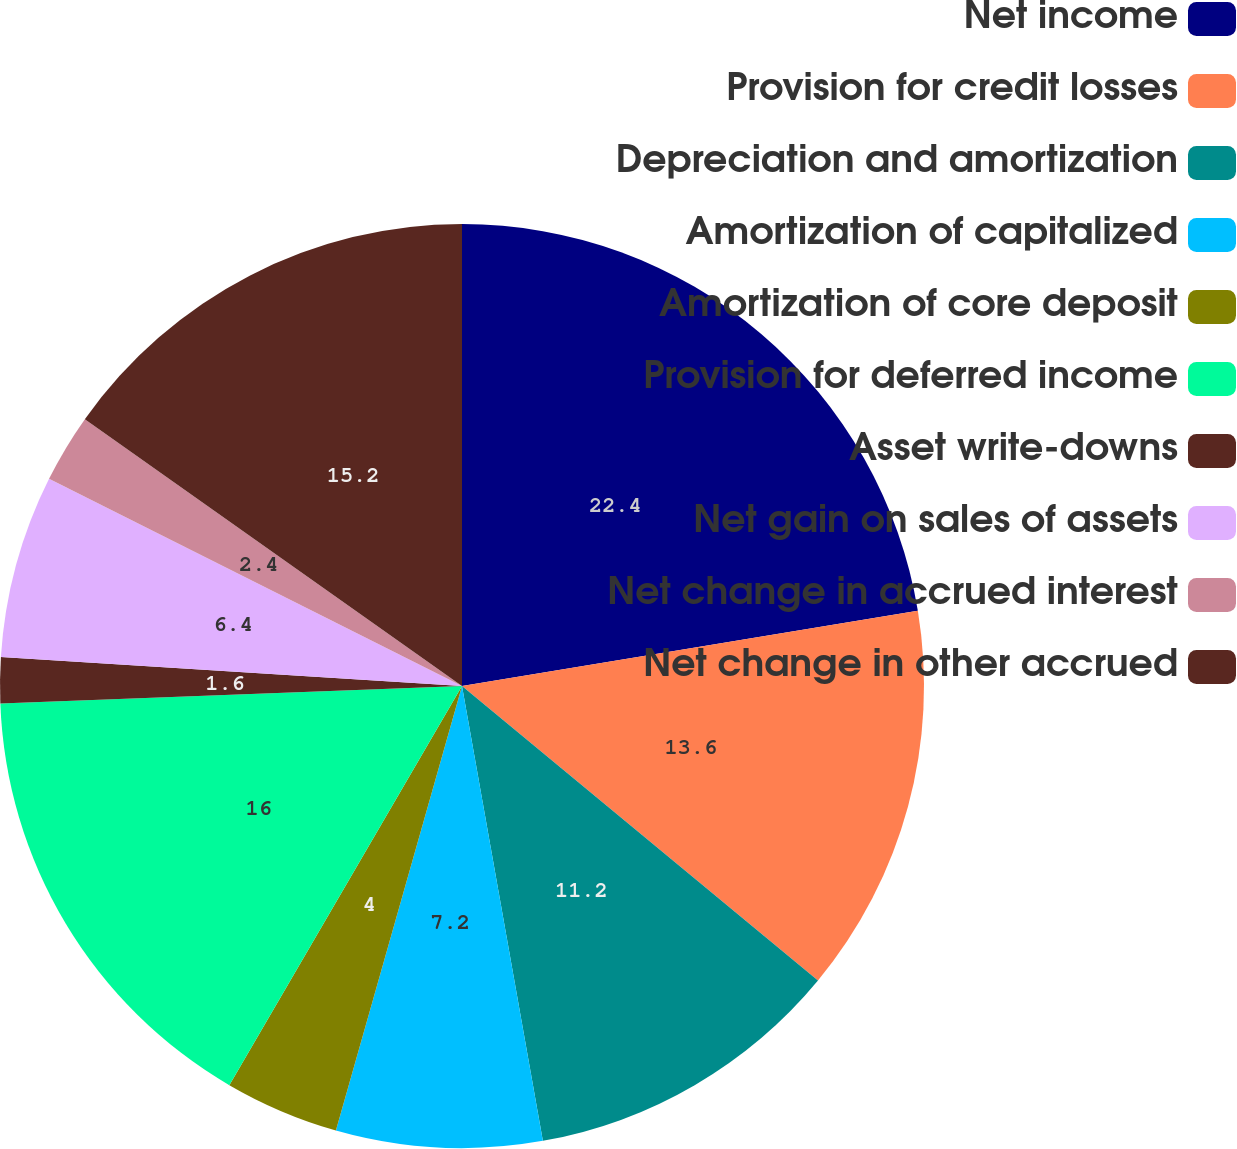Convert chart to OTSL. <chart><loc_0><loc_0><loc_500><loc_500><pie_chart><fcel>Net income<fcel>Provision for credit losses<fcel>Depreciation and amortization<fcel>Amortization of capitalized<fcel>Amortization of core deposit<fcel>Provision for deferred income<fcel>Asset write-downs<fcel>Net gain on sales of assets<fcel>Net change in accrued interest<fcel>Net change in other accrued<nl><fcel>22.4%<fcel>13.6%<fcel>11.2%<fcel>7.2%<fcel>4.0%<fcel>16.0%<fcel>1.6%<fcel>6.4%<fcel>2.4%<fcel>15.2%<nl></chart> 